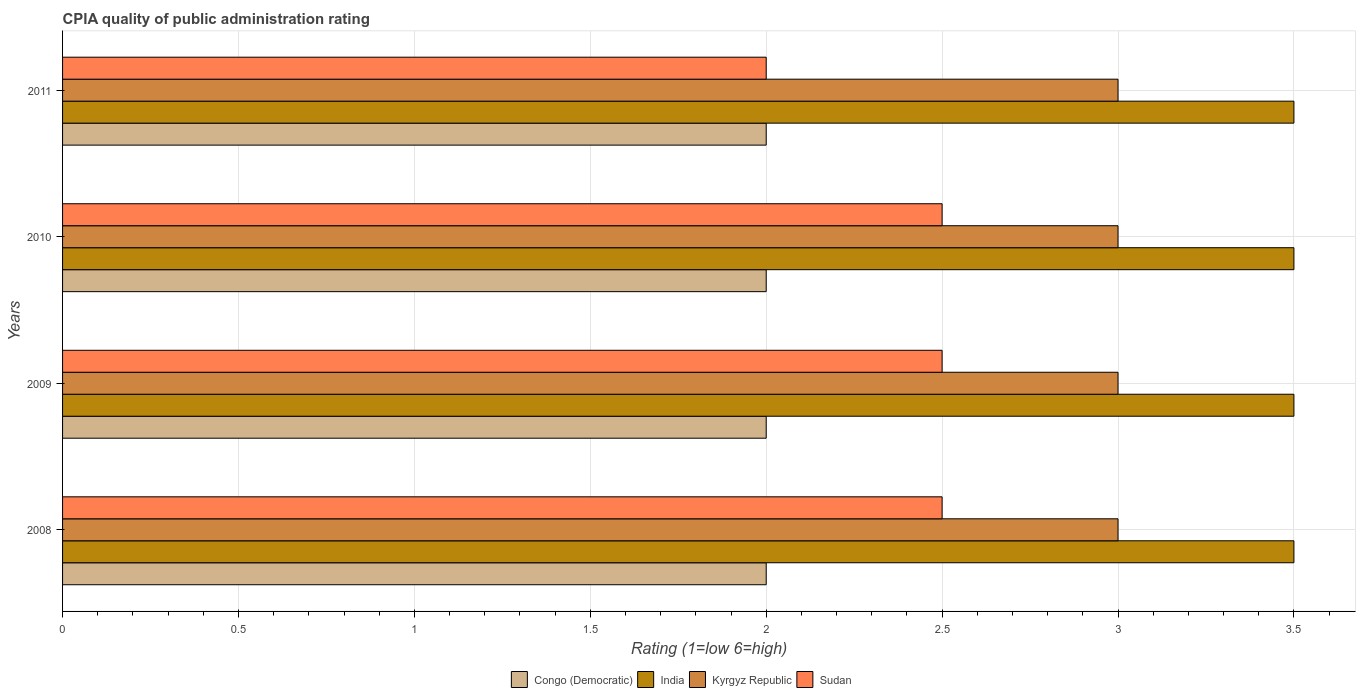How many groups of bars are there?
Your response must be concise. 4. How many bars are there on the 3rd tick from the bottom?
Provide a succinct answer. 4. What is the label of the 2nd group of bars from the top?
Keep it short and to the point. 2010. In how many cases, is the number of bars for a given year not equal to the number of legend labels?
Your response must be concise. 0. Across all years, what is the minimum CPIA rating in Sudan?
Make the answer very short. 2. In which year was the CPIA rating in India maximum?
Ensure brevity in your answer.  2008. In which year was the CPIA rating in Kyrgyz Republic minimum?
Offer a terse response. 2008. What is the total CPIA rating in Sudan in the graph?
Make the answer very short. 9.5. What is the difference between the CPIA rating in Congo (Democratic) in 2009 and that in 2011?
Your answer should be very brief. 0. What is the difference between the CPIA rating in Congo (Democratic) in 2009 and the CPIA rating in Kyrgyz Republic in 2011?
Your response must be concise. -1. What is the ratio of the CPIA rating in Congo (Democratic) in 2009 to that in 2010?
Your response must be concise. 1. Is the CPIA rating in Kyrgyz Republic in 2008 less than that in 2010?
Offer a terse response. No. Is the difference between the CPIA rating in India in 2008 and 2009 greater than the difference between the CPIA rating in Sudan in 2008 and 2009?
Your answer should be compact. No. What does the 1st bar from the bottom in 2009 represents?
Your answer should be very brief. Congo (Democratic). How many years are there in the graph?
Keep it short and to the point. 4. Are the values on the major ticks of X-axis written in scientific E-notation?
Offer a very short reply. No. Does the graph contain any zero values?
Provide a succinct answer. No. Does the graph contain grids?
Give a very brief answer. Yes. How many legend labels are there?
Provide a short and direct response. 4. How are the legend labels stacked?
Offer a terse response. Horizontal. What is the title of the graph?
Give a very brief answer. CPIA quality of public administration rating. Does "Korea (Democratic)" appear as one of the legend labels in the graph?
Offer a very short reply. No. What is the label or title of the Y-axis?
Give a very brief answer. Years. What is the Rating (1=low 6=high) in Congo (Democratic) in 2008?
Your response must be concise. 2. What is the Rating (1=low 6=high) in India in 2008?
Provide a short and direct response. 3.5. What is the Rating (1=low 6=high) in Sudan in 2008?
Your response must be concise. 2.5. What is the Rating (1=low 6=high) of Kyrgyz Republic in 2009?
Keep it short and to the point. 3. What is the Rating (1=low 6=high) of India in 2010?
Make the answer very short. 3.5. What is the Rating (1=low 6=high) of Sudan in 2010?
Make the answer very short. 2.5. What is the Rating (1=low 6=high) of Congo (Democratic) in 2011?
Make the answer very short. 2. What is the Rating (1=low 6=high) in India in 2011?
Ensure brevity in your answer.  3.5. What is the Rating (1=low 6=high) in Sudan in 2011?
Your answer should be very brief. 2. Across all years, what is the maximum Rating (1=low 6=high) in India?
Make the answer very short. 3.5. Across all years, what is the maximum Rating (1=low 6=high) in Kyrgyz Republic?
Provide a succinct answer. 3. Across all years, what is the maximum Rating (1=low 6=high) in Sudan?
Provide a short and direct response. 2.5. What is the total Rating (1=low 6=high) in India in the graph?
Provide a short and direct response. 14. What is the total Rating (1=low 6=high) of Kyrgyz Republic in the graph?
Provide a succinct answer. 12. What is the difference between the Rating (1=low 6=high) in India in 2008 and that in 2009?
Your response must be concise. 0. What is the difference between the Rating (1=low 6=high) in Kyrgyz Republic in 2008 and that in 2009?
Provide a succinct answer. 0. What is the difference between the Rating (1=low 6=high) in Congo (Democratic) in 2008 and that in 2010?
Provide a short and direct response. 0. What is the difference between the Rating (1=low 6=high) in India in 2008 and that in 2010?
Provide a short and direct response. 0. What is the difference between the Rating (1=low 6=high) of Kyrgyz Republic in 2008 and that in 2010?
Provide a succinct answer. 0. What is the difference between the Rating (1=low 6=high) of Sudan in 2008 and that in 2010?
Your response must be concise. 0. What is the difference between the Rating (1=low 6=high) of Kyrgyz Republic in 2008 and that in 2011?
Keep it short and to the point. 0. What is the difference between the Rating (1=low 6=high) of Congo (Democratic) in 2009 and that in 2010?
Provide a short and direct response. 0. What is the difference between the Rating (1=low 6=high) in Kyrgyz Republic in 2009 and that in 2010?
Your answer should be very brief. 0. What is the difference between the Rating (1=low 6=high) in Sudan in 2009 and that in 2010?
Your response must be concise. 0. What is the difference between the Rating (1=low 6=high) in Congo (Democratic) in 2009 and that in 2011?
Offer a very short reply. 0. What is the difference between the Rating (1=low 6=high) of India in 2009 and that in 2011?
Your answer should be very brief. 0. What is the difference between the Rating (1=low 6=high) in India in 2010 and that in 2011?
Ensure brevity in your answer.  0. What is the difference between the Rating (1=low 6=high) in Congo (Democratic) in 2008 and the Rating (1=low 6=high) in India in 2009?
Keep it short and to the point. -1.5. What is the difference between the Rating (1=low 6=high) in Congo (Democratic) in 2008 and the Rating (1=low 6=high) in Kyrgyz Republic in 2009?
Keep it short and to the point. -1. What is the difference between the Rating (1=low 6=high) of India in 2008 and the Rating (1=low 6=high) of Kyrgyz Republic in 2009?
Provide a short and direct response. 0.5. What is the difference between the Rating (1=low 6=high) in Congo (Democratic) in 2008 and the Rating (1=low 6=high) in India in 2010?
Provide a short and direct response. -1.5. What is the difference between the Rating (1=low 6=high) in Congo (Democratic) in 2008 and the Rating (1=low 6=high) in Kyrgyz Republic in 2010?
Your answer should be compact. -1. What is the difference between the Rating (1=low 6=high) in Congo (Democratic) in 2008 and the Rating (1=low 6=high) in Sudan in 2010?
Provide a short and direct response. -0.5. What is the difference between the Rating (1=low 6=high) in India in 2008 and the Rating (1=low 6=high) in Kyrgyz Republic in 2010?
Make the answer very short. 0.5. What is the difference between the Rating (1=low 6=high) in India in 2008 and the Rating (1=low 6=high) in Sudan in 2010?
Make the answer very short. 1. What is the difference between the Rating (1=low 6=high) in Congo (Democratic) in 2008 and the Rating (1=low 6=high) in Kyrgyz Republic in 2011?
Make the answer very short. -1. What is the difference between the Rating (1=low 6=high) in India in 2008 and the Rating (1=low 6=high) in Kyrgyz Republic in 2011?
Make the answer very short. 0.5. What is the difference between the Rating (1=low 6=high) in Kyrgyz Republic in 2008 and the Rating (1=low 6=high) in Sudan in 2011?
Your response must be concise. 1. What is the difference between the Rating (1=low 6=high) of Congo (Democratic) in 2009 and the Rating (1=low 6=high) of India in 2010?
Keep it short and to the point. -1.5. What is the difference between the Rating (1=low 6=high) in Congo (Democratic) in 2009 and the Rating (1=low 6=high) in Kyrgyz Republic in 2010?
Keep it short and to the point. -1. What is the difference between the Rating (1=low 6=high) of Congo (Democratic) in 2009 and the Rating (1=low 6=high) of Sudan in 2010?
Make the answer very short. -0.5. What is the difference between the Rating (1=low 6=high) of India in 2009 and the Rating (1=low 6=high) of Kyrgyz Republic in 2010?
Provide a succinct answer. 0.5. What is the difference between the Rating (1=low 6=high) of Congo (Democratic) in 2009 and the Rating (1=low 6=high) of Sudan in 2011?
Ensure brevity in your answer.  0. What is the difference between the Rating (1=low 6=high) of India in 2009 and the Rating (1=low 6=high) of Sudan in 2011?
Give a very brief answer. 1.5. What is the difference between the Rating (1=low 6=high) in Congo (Democratic) in 2010 and the Rating (1=low 6=high) in India in 2011?
Give a very brief answer. -1.5. What is the difference between the Rating (1=low 6=high) of Congo (Democratic) in 2010 and the Rating (1=low 6=high) of Kyrgyz Republic in 2011?
Provide a succinct answer. -1. What is the difference between the Rating (1=low 6=high) of Congo (Democratic) in 2010 and the Rating (1=low 6=high) of Sudan in 2011?
Your response must be concise. 0. What is the difference between the Rating (1=low 6=high) of India in 2010 and the Rating (1=low 6=high) of Kyrgyz Republic in 2011?
Ensure brevity in your answer.  0.5. What is the average Rating (1=low 6=high) in Sudan per year?
Your answer should be compact. 2.38. In the year 2008, what is the difference between the Rating (1=low 6=high) of Congo (Democratic) and Rating (1=low 6=high) of Kyrgyz Republic?
Give a very brief answer. -1. In the year 2008, what is the difference between the Rating (1=low 6=high) in Congo (Democratic) and Rating (1=low 6=high) in Sudan?
Offer a terse response. -0.5. In the year 2009, what is the difference between the Rating (1=low 6=high) in Congo (Democratic) and Rating (1=low 6=high) in India?
Offer a very short reply. -1.5. In the year 2009, what is the difference between the Rating (1=low 6=high) in Congo (Democratic) and Rating (1=low 6=high) in Kyrgyz Republic?
Keep it short and to the point. -1. In the year 2009, what is the difference between the Rating (1=low 6=high) in Congo (Democratic) and Rating (1=low 6=high) in Sudan?
Provide a short and direct response. -0.5. In the year 2009, what is the difference between the Rating (1=low 6=high) of India and Rating (1=low 6=high) of Kyrgyz Republic?
Keep it short and to the point. 0.5. In the year 2009, what is the difference between the Rating (1=low 6=high) in Kyrgyz Republic and Rating (1=low 6=high) in Sudan?
Your response must be concise. 0.5. In the year 2010, what is the difference between the Rating (1=low 6=high) in Congo (Democratic) and Rating (1=low 6=high) in Kyrgyz Republic?
Your response must be concise. -1. In the year 2010, what is the difference between the Rating (1=low 6=high) of India and Rating (1=low 6=high) of Kyrgyz Republic?
Your response must be concise. 0.5. In the year 2010, what is the difference between the Rating (1=low 6=high) of India and Rating (1=low 6=high) of Sudan?
Give a very brief answer. 1. In the year 2010, what is the difference between the Rating (1=low 6=high) of Kyrgyz Republic and Rating (1=low 6=high) of Sudan?
Provide a short and direct response. 0.5. In the year 2011, what is the difference between the Rating (1=low 6=high) of Congo (Democratic) and Rating (1=low 6=high) of Sudan?
Offer a very short reply. 0. In the year 2011, what is the difference between the Rating (1=low 6=high) of India and Rating (1=low 6=high) of Sudan?
Your answer should be very brief. 1.5. In the year 2011, what is the difference between the Rating (1=low 6=high) of Kyrgyz Republic and Rating (1=low 6=high) of Sudan?
Offer a very short reply. 1. What is the ratio of the Rating (1=low 6=high) in Congo (Democratic) in 2008 to that in 2009?
Give a very brief answer. 1. What is the ratio of the Rating (1=low 6=high) in Kyrgyz Republic in 2008 to that in 2009?
Offer a terse response. 1. What is the ratio of the Rating (1=low 6=high) of Congo (Democratic) in 2008 to that in 2010?
Give a very brief answer. 1. What is the ratio of the Rating (1=low 6=high) of India in 2008 to that in 2010?
Ensure brevity in your answer.  1. What is the ratio of the Rating (1=low 6=high) of Congo (Democratic) in 2008 to that in 2011?
Provide a succinct answer. 1. What is the ratio of the Rating (1=low 6=high) in India in 2008 to that in 2011?
Give a very brief answer. 1. What is the ratio of the Rating (1=low 6=high) in Kyrgyz Republic in 2008 to that in 2011?
Provide a short and direct response. 1. What is the ratio of the Rating (1=low 6=high) of Sudan in 2008 to that in 2011?
Ensure brevity in your answer.  1.25. What is the ratio of the Rating (1=low 6=high) in India in 2009 to that in 2010?
Make the answer very short. 1. What is the ratio of the Rating (1=low 6=high) of Kyrgyz Republic in 2009 to that in 2010?
Your answer should be compact. 1. What is the ratio of the Rating (1=low 6=high) of Congo (Democratic) in 2009 to that in 2011?
Make the answer very short. 1. What is the ratio of the Rating (1=low 6=high) of Kyrgyz Republic in 2009 to that in 2011?
Your response must be concise. 1. What is the ratio of the Rating (1=low 6=high) in Kyrgyz Republic in 2010 to that in 2011?
Keep it short and to the point. 1. What is the difference between the highest and the second highest Rating (1=low 6=high) of Congo (Democratic)?
Keep it short and to the point. 0. What is the difference between the highest and the second highest Rating (1=low 6=high) of India?
Give a very brief answer. 0. What is the difference between the highest and the second highest Rating (1=low 6=high) of Kyrgyz Republic?
Your answer should be very brief. 0. What is the difference between the highest and the second highest Rating (1=low 6=high) in Sudan?
Your answer should be compact. 0. What is the difference between the highest and the lowest Rating (1=low 6=high) of India?
Your answer should be very brief. 0. What is the difference between the highest and the lowest Rating (1=low 6=high) of Sudan?
Offer a terse response. 0.5. 